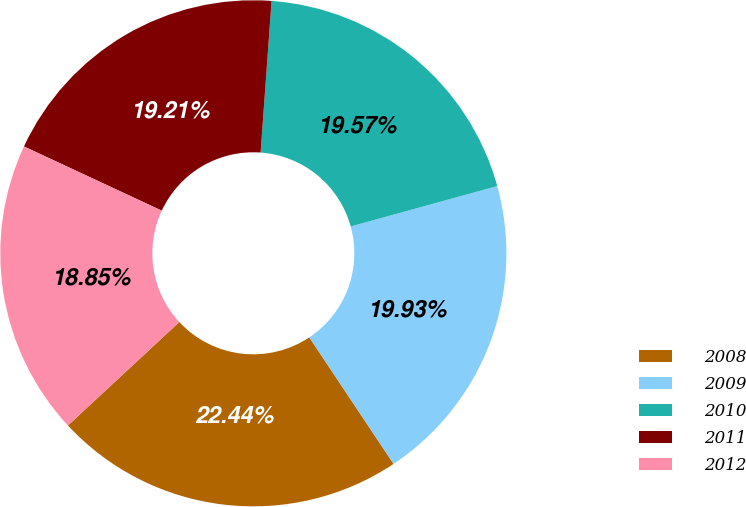Convert chart. <chart><loc_0><loc_0><loc_500><loc_500><pie_chart><fcel>2008<fcel>2009<fcel>2010<fcel>2011<fcel>2012<nl><fcel>22.44%<fcel>19.93%<fcel>19.57%<fcel>19.21%<fcel>18.85%<nl></chart> 